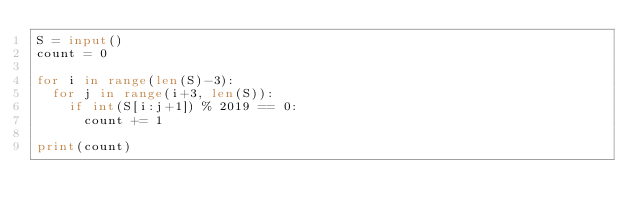Convert code to text. <code><loc_0><loc_0><loc_500><loc_500><_Python_>S = input()
count = 0

for i in range(len(S)-3):
  for j in range(i+3, len(S)):
    if int(S[i:j+1]) % 2019 == 0:
      count += 1

print(count)</code> 